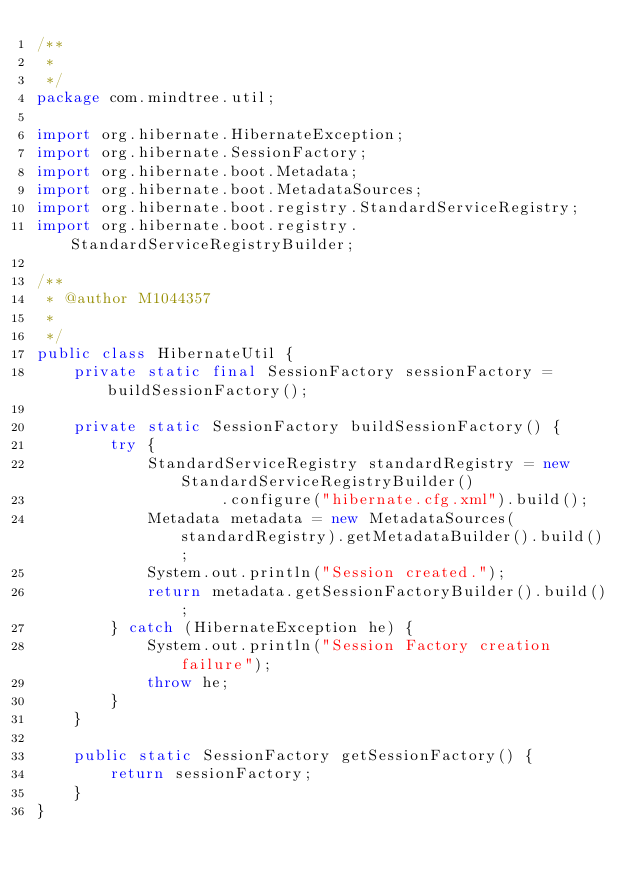<code> <loc_0><loc_0><loc_500><loc_500><_Java_>/**
 * 
 */
package com.mindtree.util;

import org.hibernate.HibernateException;
import org.hibernate.SessionFactory;
import org.hibernate.boot.Metadata;
import org.hibernate.boot.MetadataSources;
import org.hibernate.boot.registry.StandardServiceRegistry;
import org.hibernate.boot.registry.StandardServiceRegistryBuilder;

/**
 * @author M1044357
 *
 */
public class HibernateUtil {
    private static final SessionFactory sessionFactory = buildSessionFactory();

    private static SessionFactory buildSessionFactory() {
        try {
            StandardServiceRegistry standardRegistry = new StandardServiceRegistryBuilder()
                    .configure("hibernate.cfg.xml").build();
            Metadata metadata = new MetadataSources(standardRegistry).getMetadataBuilder().build();
            System.out.println("Session created.");
            return metadata.getSessionFactoryBuilder().build();
        } catch (HibernateException he) {
            System.out.println("Session Factory creation failure");
            throw he;
        }
    }

    public static SessionFactory getSessionFactory() {
        return sessionFactory;
    }
}
</code> 